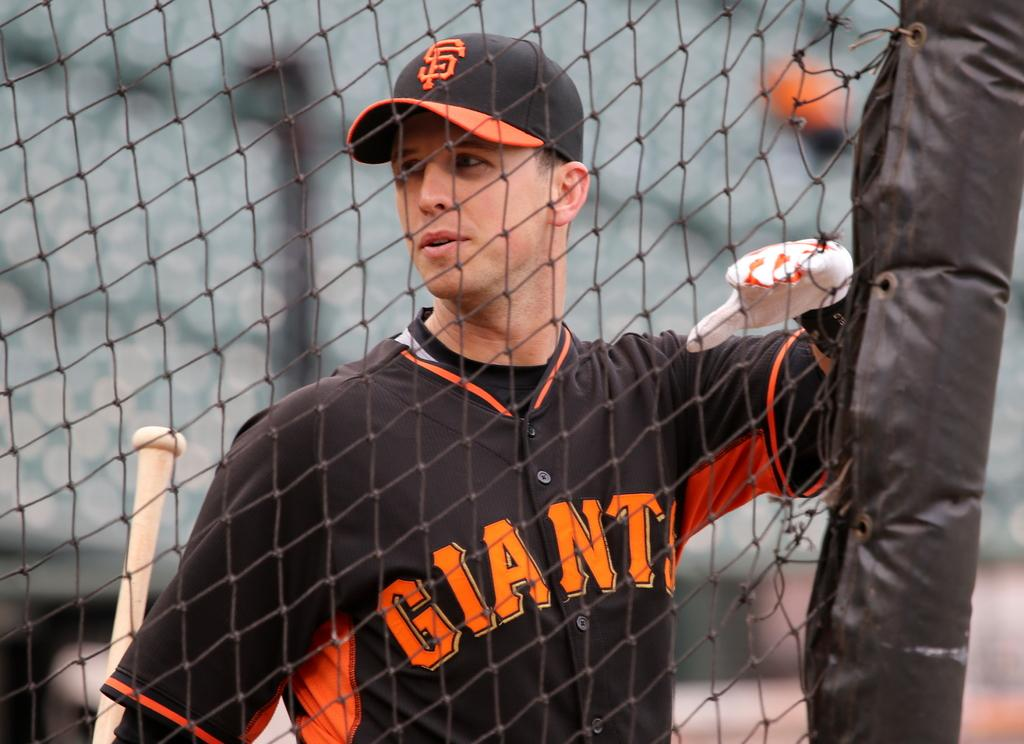<image>
Present a compact description of the photo's key features. A man wearing a Giants baseball uniform is holding a bat and standing next to a chain link fence. 